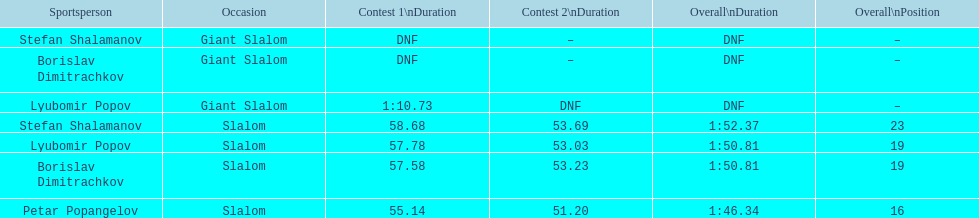Can you parse all the data within this table? {'header': ['Sportsperson', 'Occasion', 'Contest 1\\nDuration', 'Contest 2\\nDuration', 'Overall\\nDuration', 'Overall\\nPosition'], 'rows': [['Stefan Shalamanov', 'Giant Slalom', 'DNF', '–', 'DNF', '–'], ['Borislav Dimitrachkov', 'Giant Slalom', 'DNF', '–', 'DNF', '–'], ['Lyubomir Popov', 'Giant Slalom', '1:10.73', 'DNF', 'DNF', '–'], ['Stefan Shalamanov', 'Slalom', '58.68', '53.69', '1:52.37', '23'], ['Lyubomir Popov', 'Slalom', '57.78', '53.03', '1:50.81', '19'], ['Borislav Dimitrachkov', 'Slalom', '57.58', '53.23', '1:50.81', '19'], ['Petar Popangelov', 'Slalom', '55.14', '51.20', '1:46.34', '16']]} Who came after borislav dimitrachkov and it's time for slalom Petar Popangelov. 